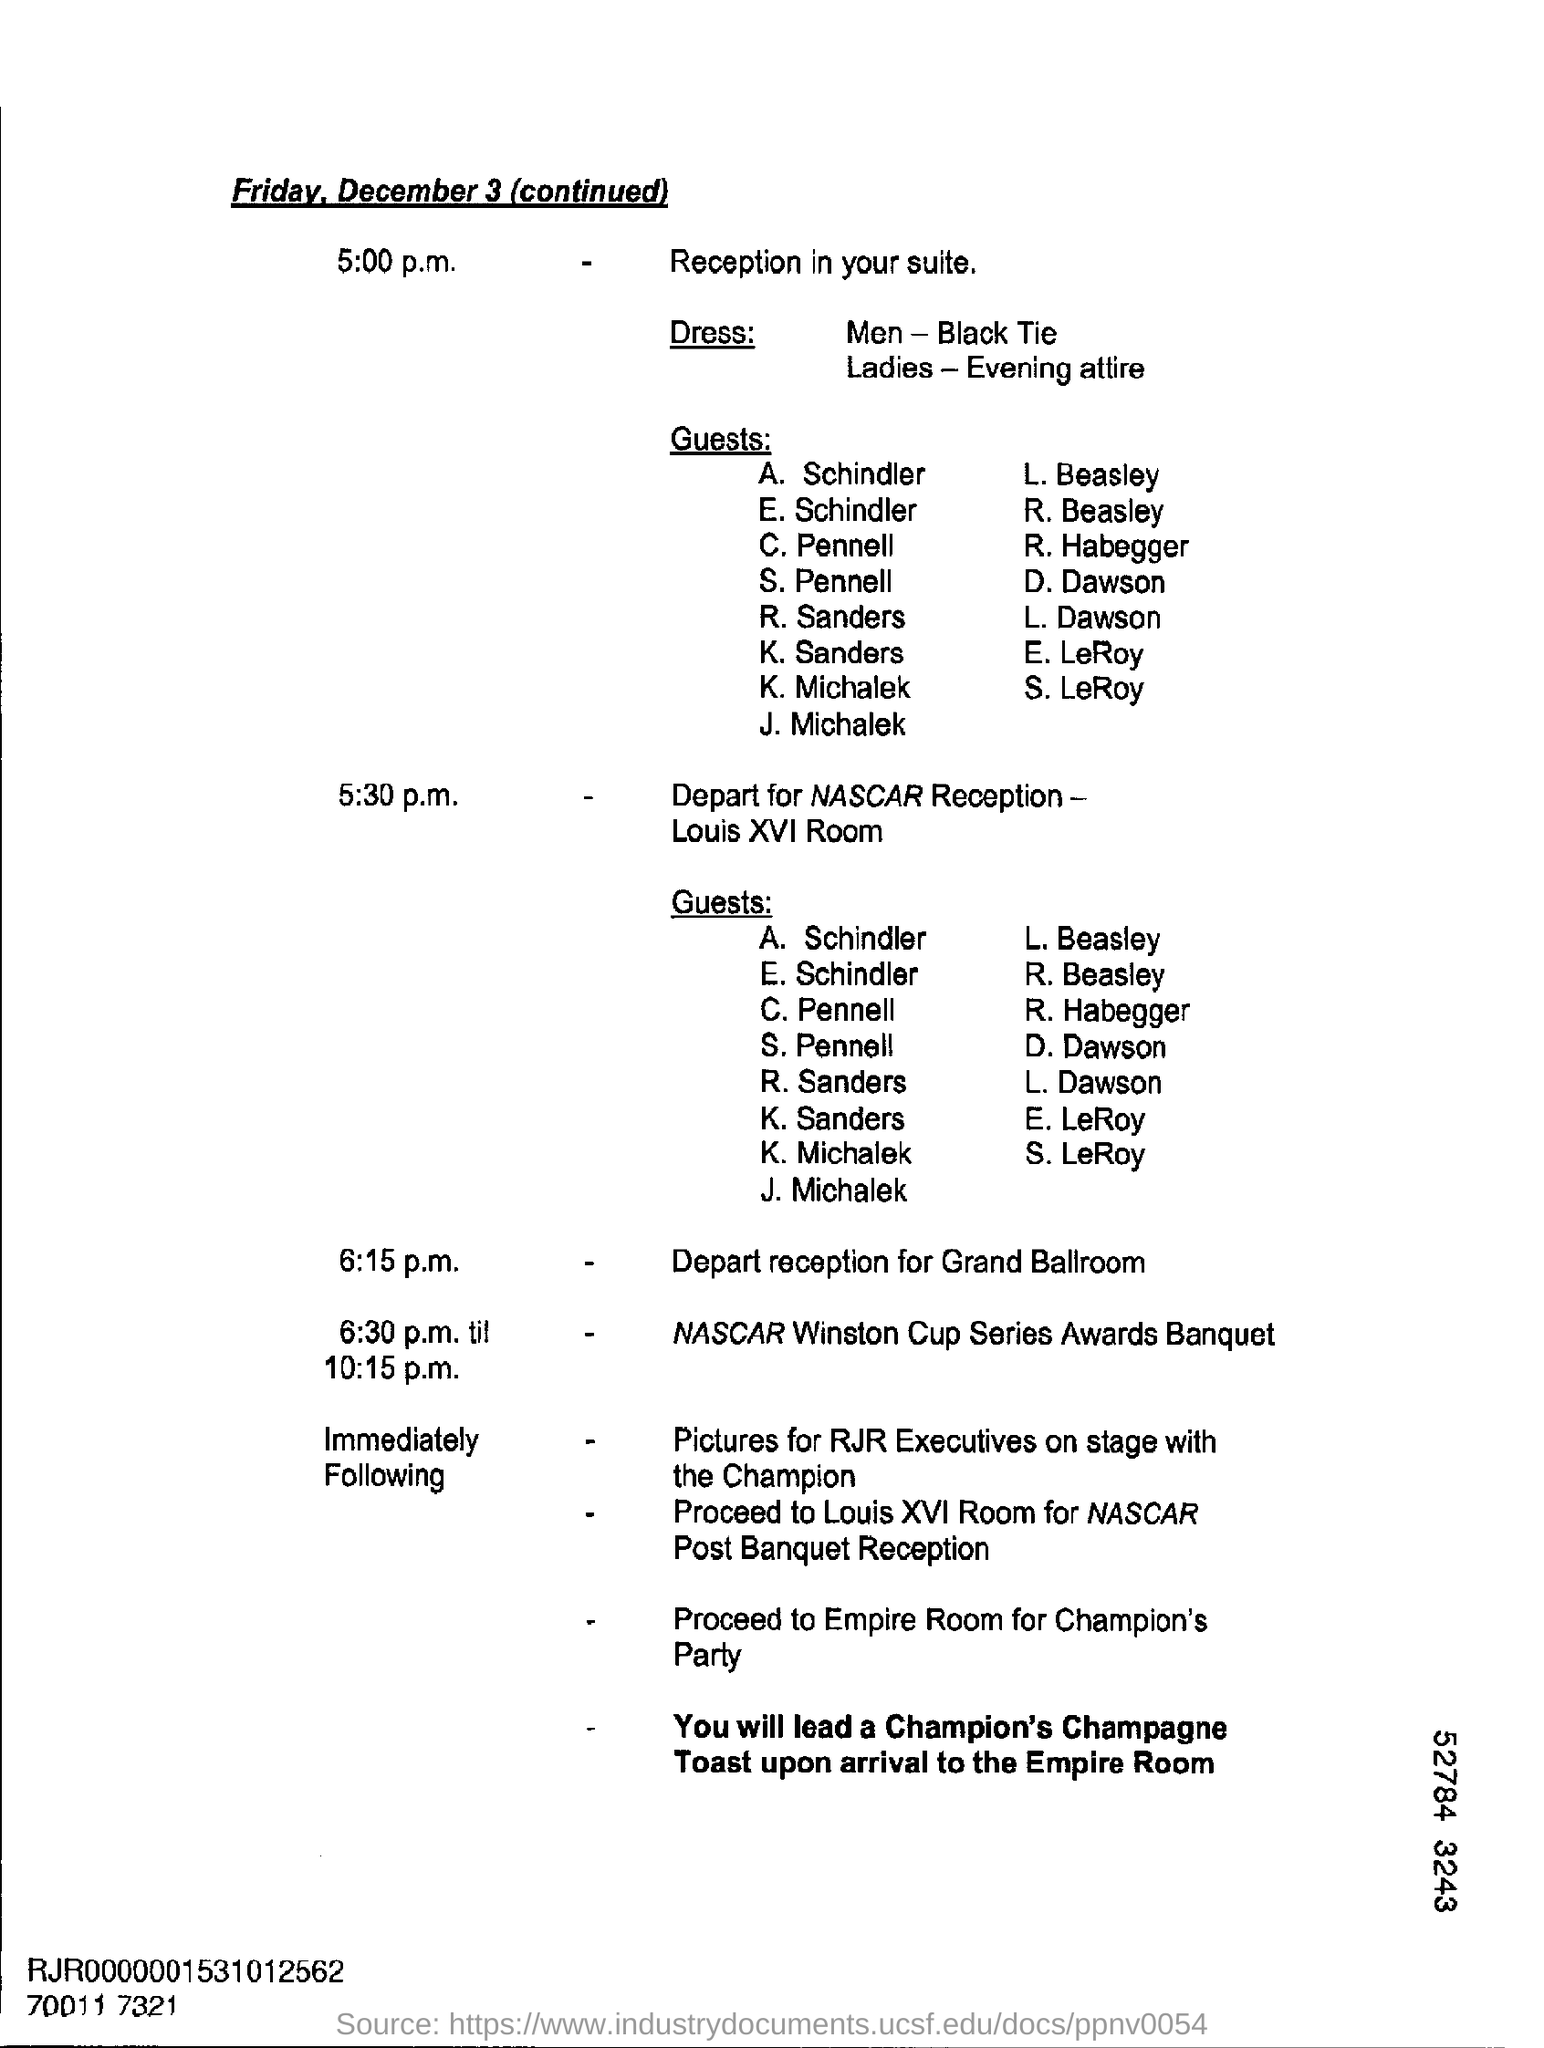What day of the week is december 3?
Keep it short and to the point. Friday. When is the depart reception for grand ball room scheduled ?
Your response must be concise. 6:15 p.m. What time is reception in your suite is scheduled ?
Make the answer very short. 5:00 p.m. What is the dress code for men?
Make the answer very short. Black Tie. 